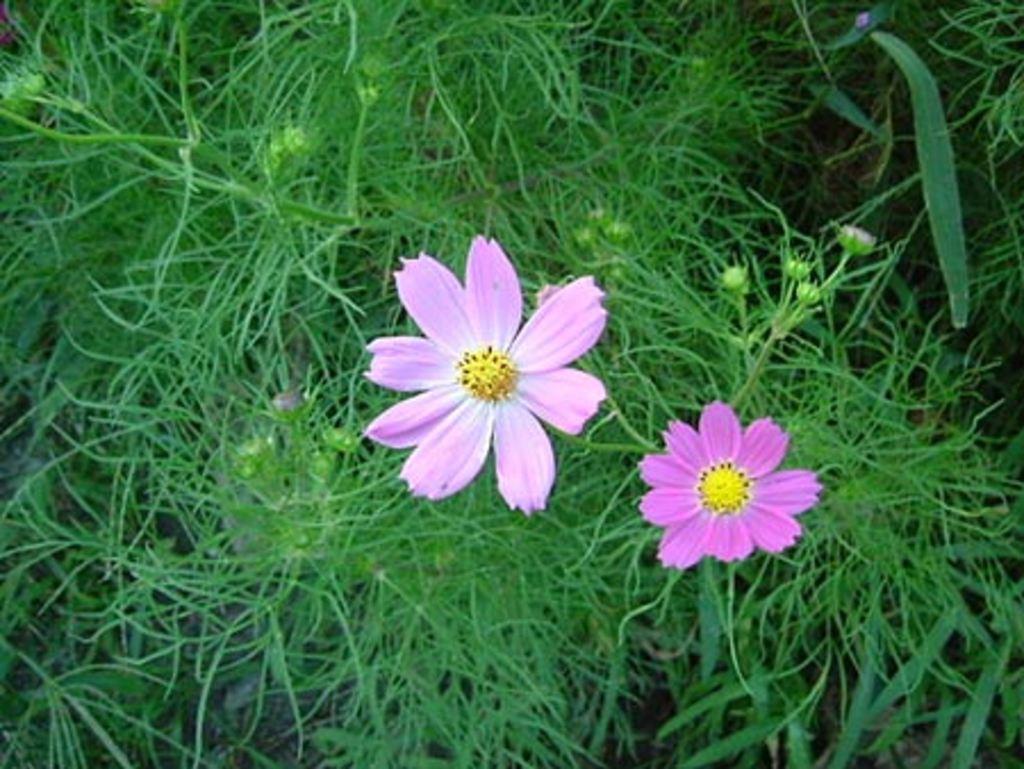In one or two sentences, can you explain what this image depicts? In this image I can see there are flowers, buds and plants. 